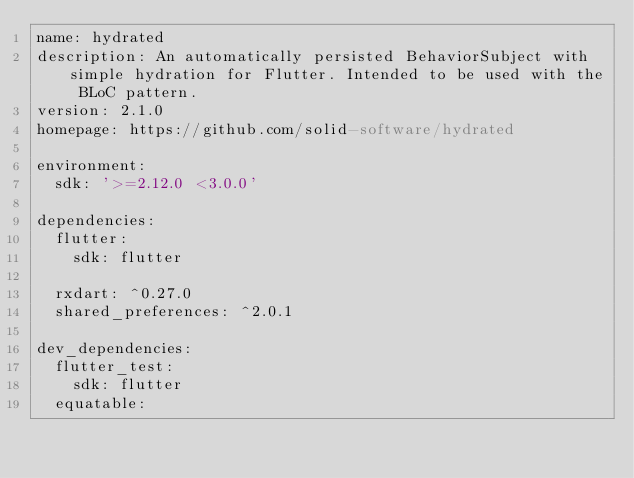Convert code to text. <code><loc_0><loc_0><loc_500><loc_500><_YAML_>name: hydrated
description: An automatically persisted BehaviorSubject with simple hydration for Flutter. Intended to be used with the BLoC pattern.
version: 2.1.0
homepage: https://github.com/solid-software/hydrated

environment:
  sdk: '>=2.12.0 <3.0.0'

dependencies:
  flutter:
    sdk: flutter

  rxdart: ^0.27.0
  shared_preferences: ^2.0.1

dev_dependencies:
  flutter_test:
    sdk: flutter
  equatable:
    </code> 